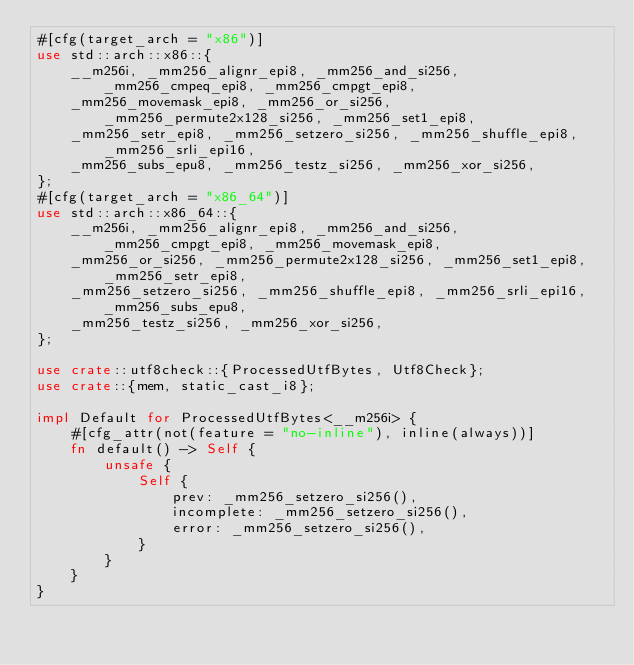<code> <loc_0><loc_0><loc_500><loc_500><_Rust_>#[cfg(target_arch = "x86")]
use std::arch::x86::{
    __m256i, _mm256_alignr_epi8, _mm256_and_si256, _mm256_cmpeq_epi8, _mm256_cmpgt_epi8,
    _mm256_movemask_epi8, _mm256_or_si256, _mm256_permute2x128_si256, _mm256_set1_epi8,
    _mm256_setr_epi8, _mm256_setzero_si256, _mm256_shuffle_epi8, _mm256_srli_epi16,
    _mm256_subs_epu8, _mm256_testz_si256, _mm256_xor_si256,
};
#[cfg(target_arch = "x86_64")]
use std::arch::x86_64::{
    __m256i, _mm256_alignr_epi8, _mm256_and_si256, _mm256_cmpgt_epi8, _mm256_movemask_epi8,
    _mm256_or_si256, _mm256_permute2x128_si256, _mm256_set1_epi8, _mm256_setr_epi8,
    _mm256_setzero_si256, _mm256_shuffle_epi8, _mm256_srli_epi16, _mm256_subs_epu8,
    _mm256_testz_si256, _mm256_xor_si256,
};

use crate::utf8check::{ProcessedUtfBytes, Utf8Check};
use crate::{mem, static_cast_i8};

impl Default for ProcessedUtfBytes<__m256i> {
    #[cfg_attr(not(feature = "no-inline"), inline(always))]
    fn default() -> Self {
        unsafe {
            Self {
                prev: _mm256_setzero_si256(),
                incomplete: _mm256_setzero_si256(),
                error: _mm256_setzero_si256(),
            }
        }
    }
}
</code> 